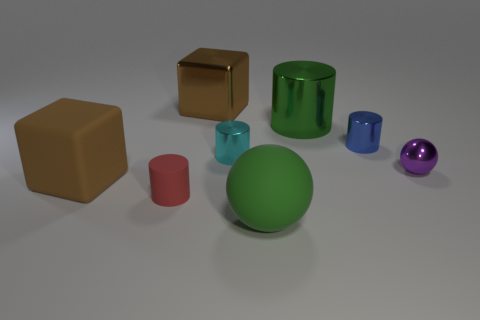There is another metallic thing that is the same size as the brown metal object; what shape is it?
Provide a succinct answer. Cylinder. Is there another tiny red thing that has the same shape as the red rubber thing?
Ensure brevity in your answer.  No. Is the red cylinder made of the same material as the large brown thing that is to the left of the brown metallic thing?
Ensure brevity in your answer.  Yes. Are there any metallic spheres that have the same color as the tiny rubber cylinder?
Make the answer very short. No. What number of other objects are the same material as the big green sphere?
Your answer should be very brief. 2. There is a small shiny ball; is it the same color as the object to the left of the red matte cylinder?
Give a very brief answer. No. Is the number of big green matte spheres that are to the left of the tiny purple metal sphere greater than the number of tiny red matte cylinders?
Provide a short and direct response. No. There is a thing that is behind the green object that is behind the green rubber ball; what number of green shiny cylinders are behind it?
Give a very brief answer. 0. There is a green object that is behind the small red matte cylinder; is its shape the same as the red matte thing?
Give a very brief answer. Yes. There is a small thing behind the small cyan cylinder; what material is it?
Your response must be concise. Metal. 